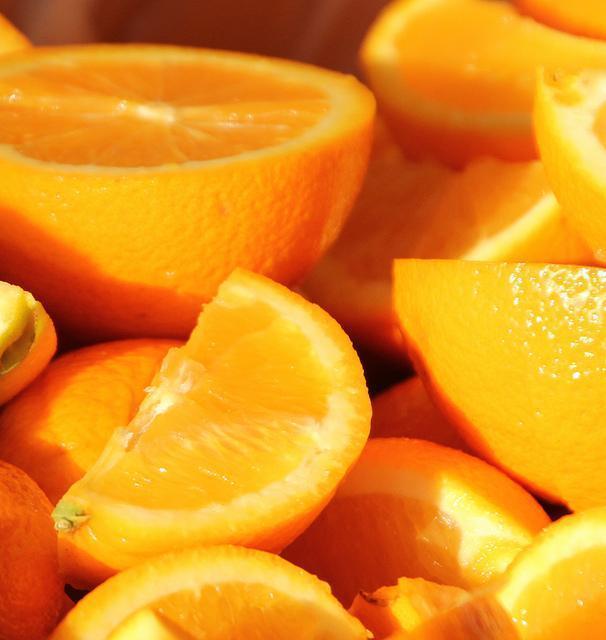How many oranges are visible?
Give a very brief answer. 13. How many people are sitting on chair?
Give a very brief answer. 0. 